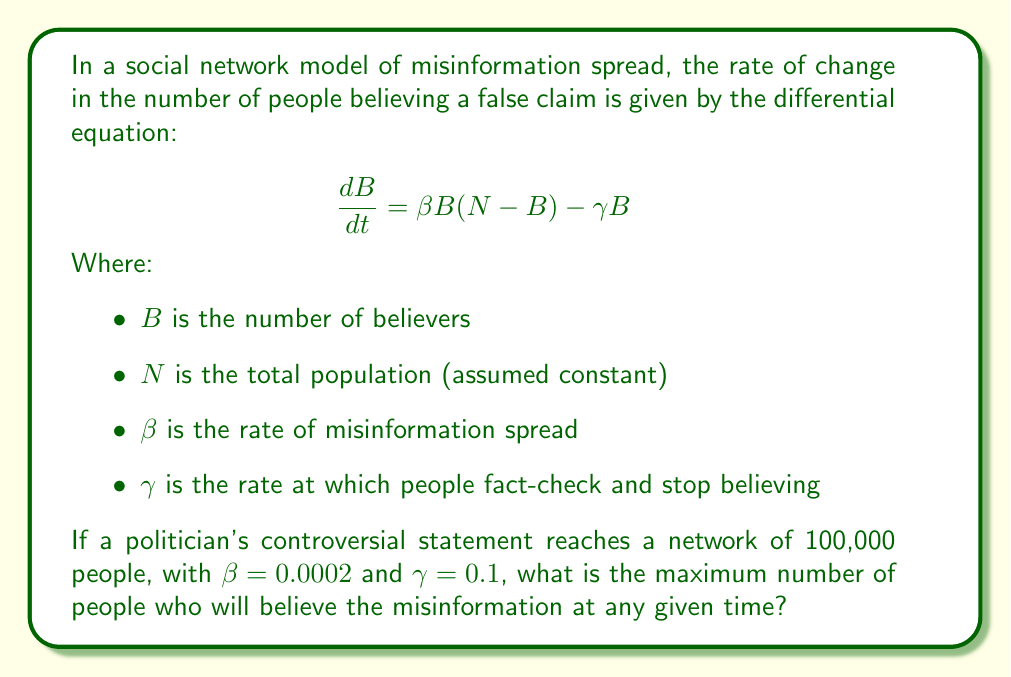Provide a solution to this math problem. To find the maximum number of believers, we need to find the equilibrium point of the differential equation where $\frac{dB}{dt} = 0$. This occurs when the rate of new believers equals the rate of people stopping to believe.

1) Set the equation equal to zero:
   $$0 = \beta B(N-B) - \gamma B$$

2) Factor out $B$:
   $$0 = B[\beta(N-B) - \gamma]$$

3) Solve for $B$ (ignoring the trivial solution $B=0$):
   $$\beta(N-B) - \gamma = 0$$
   $$\beta N - \beta B - \gamma = 0$$
   $$\beta N - \gamma = \beta B$$
   $$B = N - \frac{\gamma}{\beta}$$

4) Substitute the given values:
   $N = 100,000$
   $\beta = 0.0002$
   $\gamma = 0.1$

   $$B = 100,000 - \frac{0.1}{0.0002} = 100,000 - 500 = 99,500$$

This equilibrium point represents the maximum number of believers, as the number of believers will approach this value over time and then stabilize.
Answer: The maximum number of people who will believe the misinformation at any given time is 99,500. 